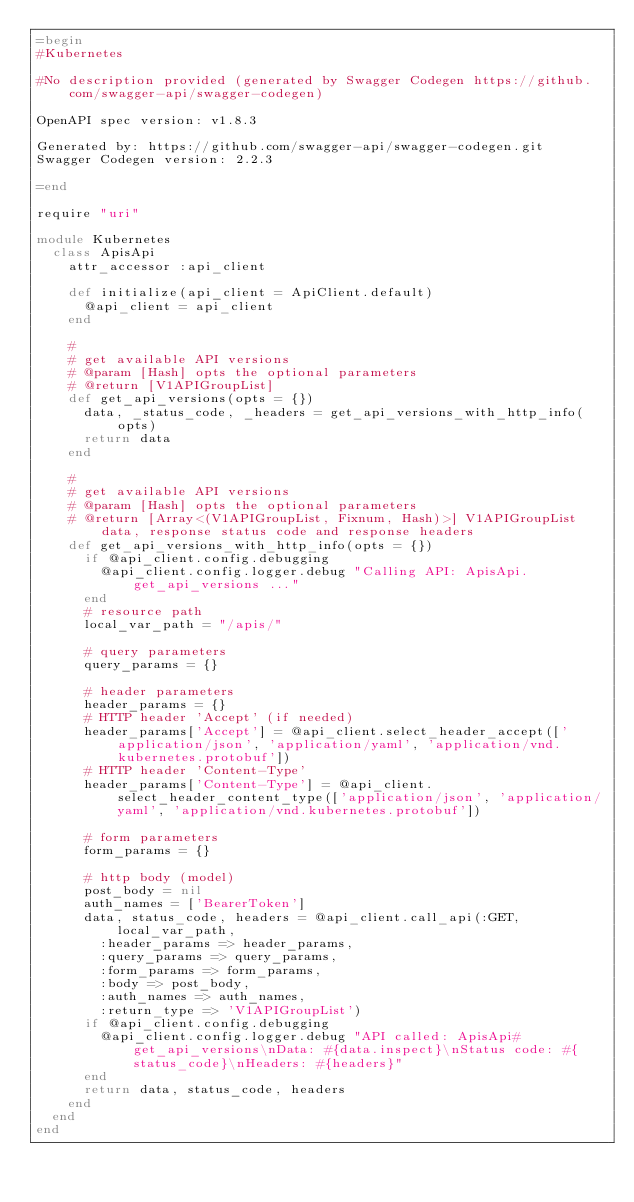<code> <loc_0><loc_0><loc_500><loc_500><_Ruby_>=begin
#Kubernetes

#No description provided (generated by Swagger Codegen https://github.com/swagger-api/swagger-codegen)

OpenAPI spec version: v1.8.3

Generated by: https://github.com/swagger-api/swagger-codegen.git
Swagger Codegen version: 2.2.3

=end

require "uri"

module Kubernetes
  class ApisApi
    attr_accessor :api_client

    def initialize(api_client = ApiClient.default)
      @api_client = api_client
    end

    # 
    # get available API versions
    # @param [Hash] opts the optional parameters
    # @return [V1APIGroupList]
    def get_api_versions(opts = {})
      data, _status_code, _headers = get_api_versions_with_http_info(opts)
      return data
    end

    # 
    # get available API versions
    # @param [Hash] opts the optional parameters
    # @return [Array<(V1APIGroupList, Fixnum, Hash)>] V1APIGroupList data, response status code and response headers
    def get_api_versions_with_http_info(opts = {})
      if @api_client.config.debugging
        @api_client.config.logger.debug "Calling API: ApisApi.get_api_versions ..."
      end
      # resource path
      local_var_path = "/apis/"

      # query parameters
      query_params = {}

      # header parameters
      header_params = {}
      # HTTP header 'Accept' (if needed)
      header_params['Accept'] = @api_client.select_header_accept(['application/json', 'application/yaml', 'application/vnd.kubernetes.protobuf'])
      # HTTP header 'Content-Type'
      header_params['Content-Type'] = @api_client.select_header_content_type(['application/json', 'application/yaml', 'application/vnd.kubernetes.protobuf'])

      # form parameters
      form_params = {}

      # http body (model)
      post_body = nil
      auth_names = ['BearerToken']
      data, status_code, headers = @api_client.call_api(:GET, local_var_path,
        :header_params => header_params,
        :query_params => query_params,
        :form_params => form_params,
        :body => post_body,
        :auth_names => auth_names,
        :return_type => 'V1APIGroupList')
      if @api_client.config.debugging
        @api_client.config.logger.debug "API called: ApisApi#get_api_versions\nData: #{data.inspect}\nStatus code: #{status_code}\nHeaders: #{headers}"
      end
      return data, status_code, headers
    end
  end
end
</code> 